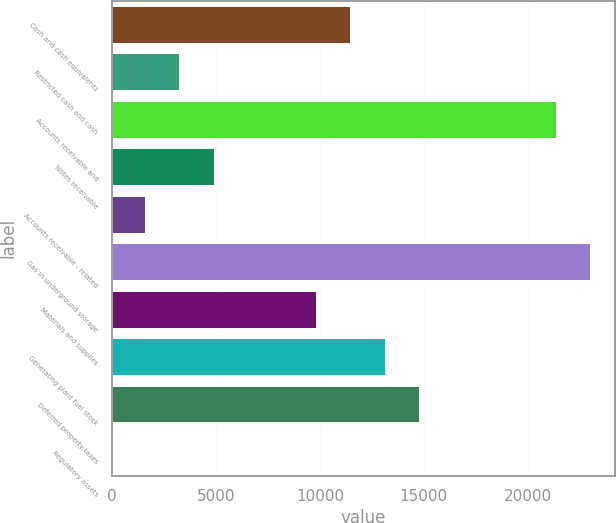Convert chart to OTSL. <chart><loc_0><loc_0><loc_500><loc_500><bar_chart><fcel>Cash and cash equivalents<fcel>Restricted cash and cash<fcel>Accounts receivable and<fcel>Notes receivable<fcel>Accounts receivable - related<fcel>Gas in underground storage<fcel>Materials and supplies<fcel>Generating plant fuel stock<fcel>Deferred property taxes<fcel>Regulatory assets<nl><fcel>11516.7<fcel>3291.2<fcel>21387.3<fcel>4936.3<fcel>1646.1<fcel>23032.4<fcel>9871.6<fcel>13161.8<fcel>14806.9<fcel>1<nl></chart> 